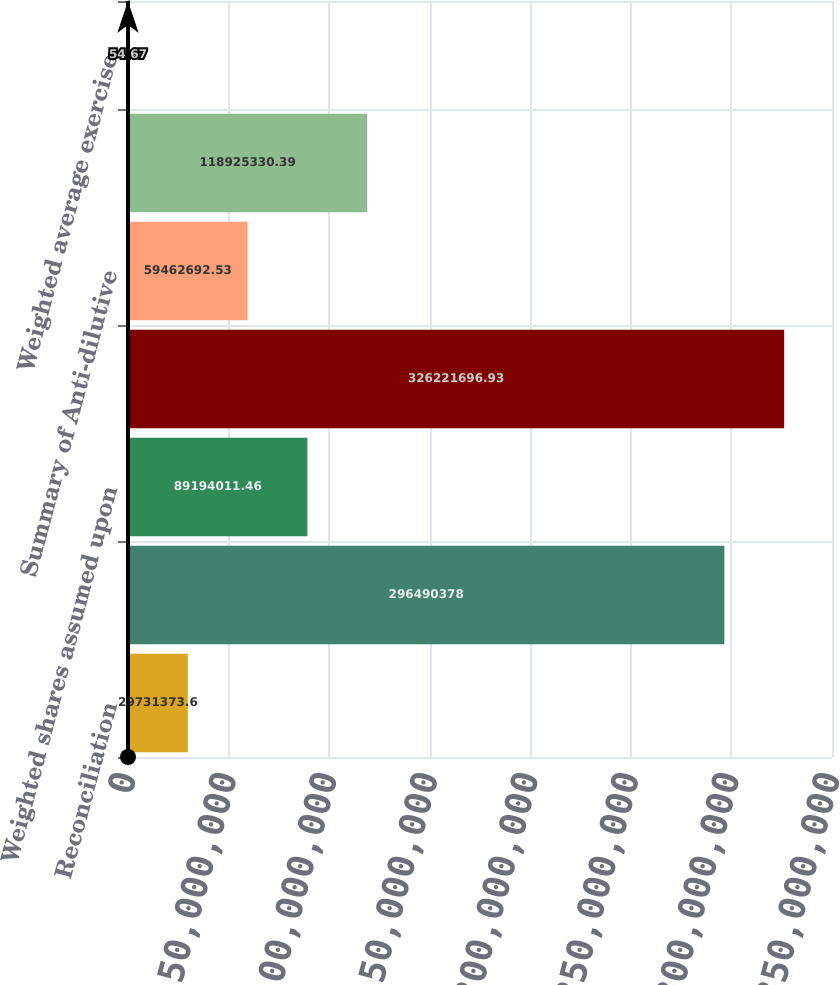Convert chart to OTSL. <chart><loc_0><loc_0><loc_500><loc_500><bar_chart><fcel>Reconciliation<fcel>Basic weighted average shares<fcel>Weighted shares assumed upon<fcel>Diluted weighted average<fcel>Summary of Anti-dilutive<fcel>Options to purchase shares of<fcel>Weighted average exercise<nl><fcel>2.97314e+07<fcel>2.9649e+08<fcel>8.9194e+07<fcel>3.26222e+08<fcel>5.94627e+07<fcel>1.18925e+08<fcel>54.67<nl></chart> 